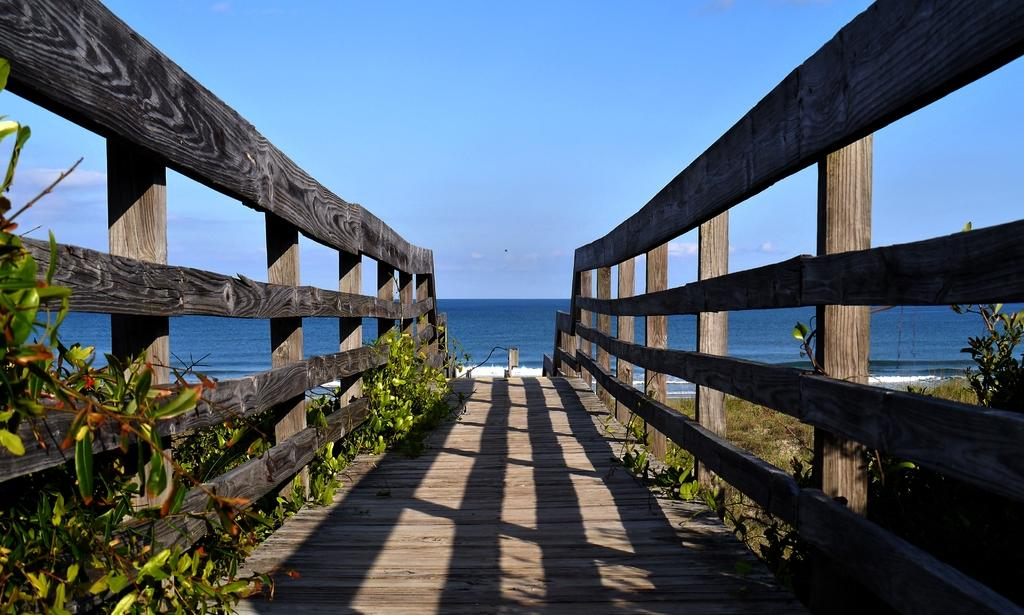What type of path is visible in the image? There is a wooden path in the image. What is present alongside the wooden path? There is fencing in the image. What kind of vegetation can be seen in the image? There are plants in the image. What is the ground surface like in the image? The ground with grass is visible in the image. What natural element is present in the image? There is water in the image. What is visible in the sky in the image? The sky with clouds is visible in the image. What type of crime is being committed in the image? There is no crime being committed in the image; it features a wooden path, fencing, plants, grass, water, and a sky with clouds. How many men are present in the image? There is no mention of men in the image; it features a wooden path, fencing, plants, grass, water, and a sky with clouds. 